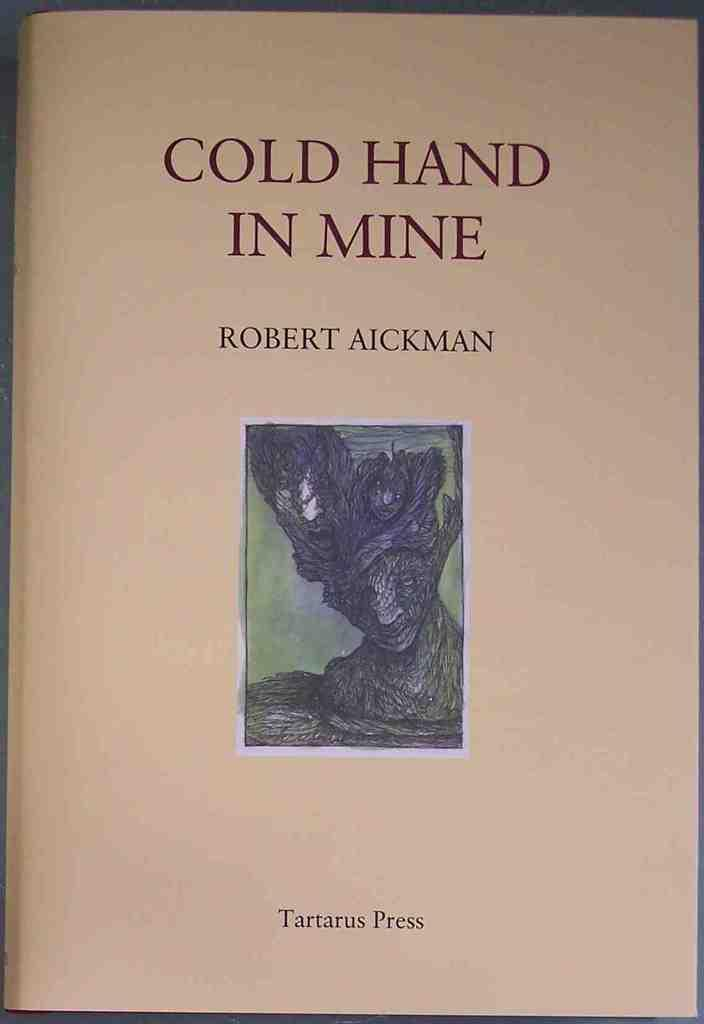Provide a one-sentence caption for the provided image. A book with a dark illustration written by Robert Aickman. 